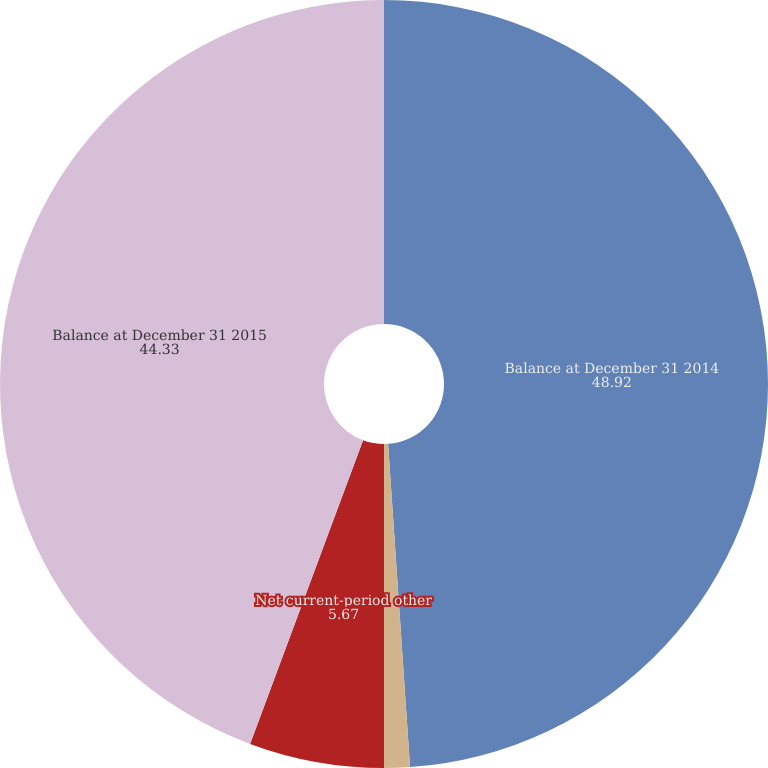Convert chart to OTSL. <chart><loc_0><loc_0><loc_500><loc_500><pie_chart><fcel>Balance at December 31 2014<fcel>Other comprehensive loss<fcel>Net current-period other<fcel>Balance at December 31 2015<nl><fcel>48.92%<fcel>1.08%<fcel>5.67%<fcel>44.33%<nl></chart> 